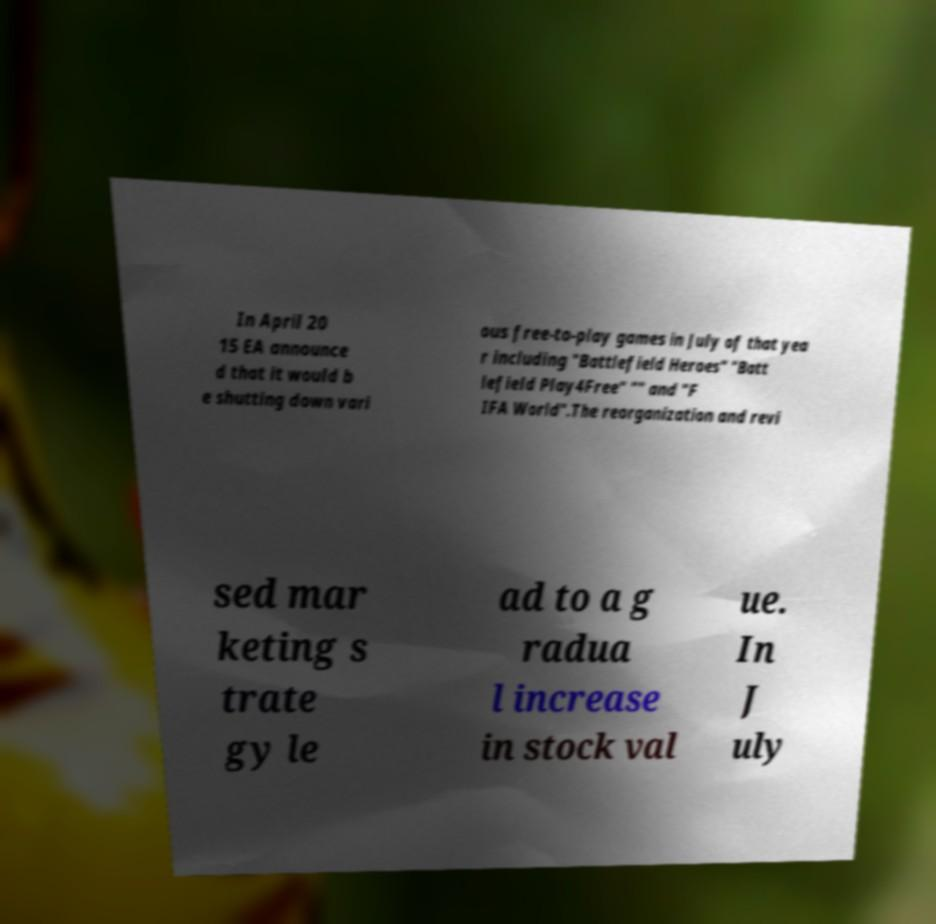For documentation purposes, I need the text within this image transcribed. Could you provide that? In April 20 15 EA announce d that it would b e shutting down vari ous free-to-play games in July of that yea r including "Battlefield Heroes" "Batt lefield Play4Free" "" and "F IFA World".The reorganization and revi sed mar keting s trate gy le ad to a g radua l increase in stock val ue. In J uly 